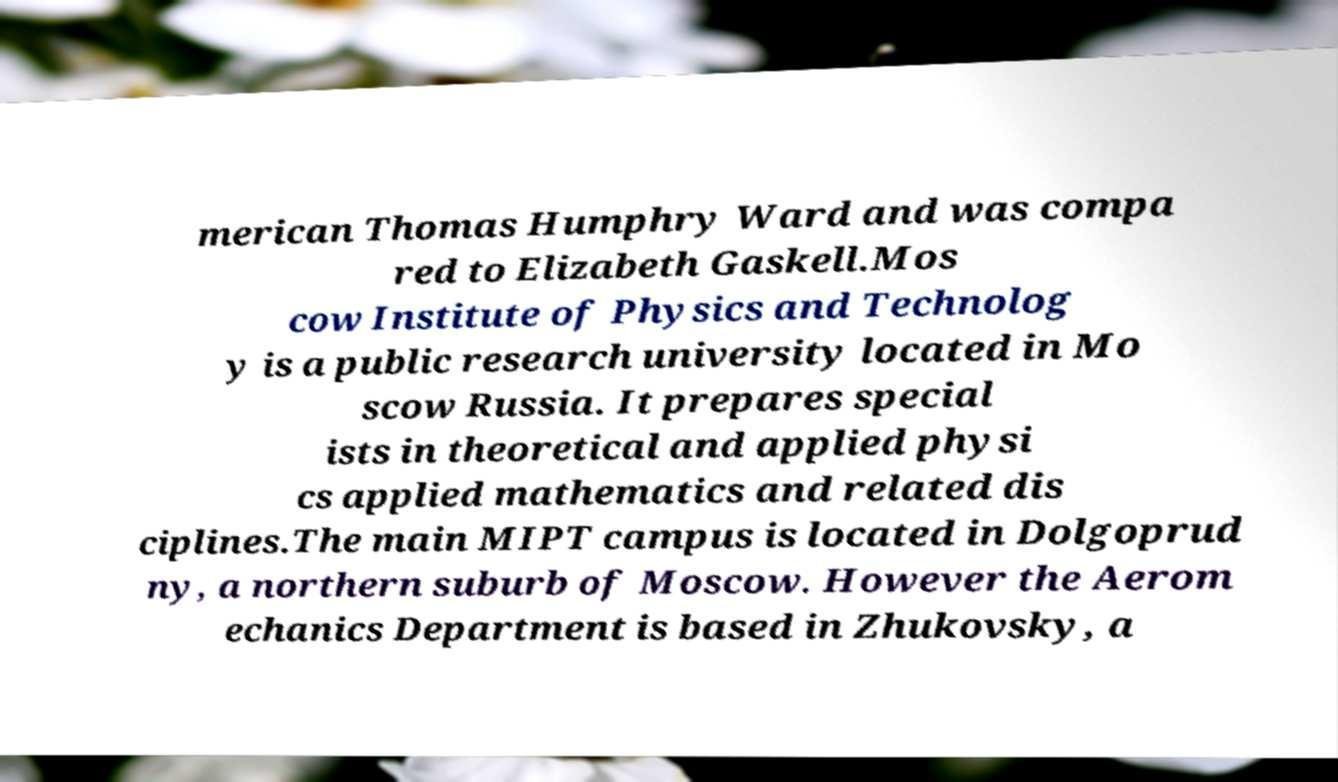Could you assist in decoding the text presented in this image and type it out clearly? merican Thomas Humphry Ward and was compa red to Elizabeth Gaskell.Mos cow Institute of Physics and Technolog y is a public research university located in Mo scow Russia. It prepares special ists in theoretical and applied physi cs applied mathematics and related dis ciplines.The main MIPT campus is located in Dolgoprud ny, a northern suburb of Moscow. However the Aerom echanics Department is based in Zhukovsky, a 